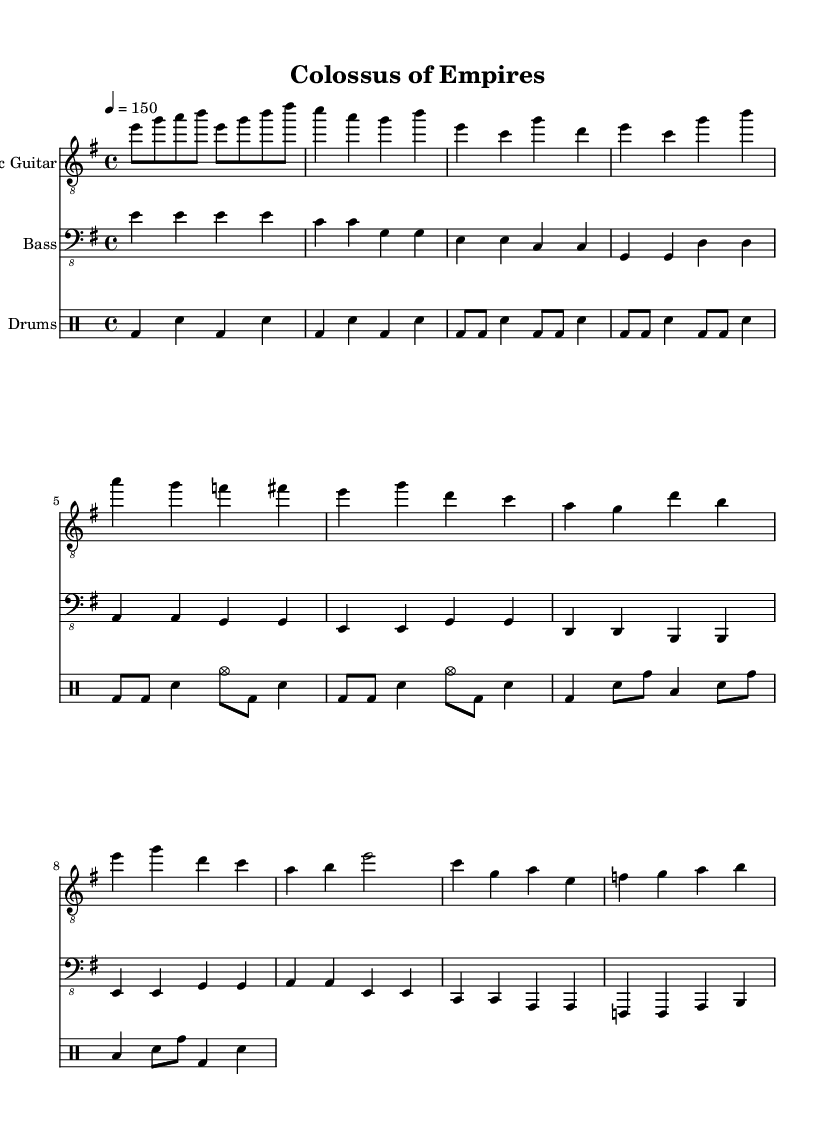What is the key signature of this music? The key signature is E minor, which has one sharp (F#). This is indicated by the 'e' in the key signature mentioned at the beginning of the score.
Answer: E minor What is the time signature of this music? The time signature is 4/4, which indicates that there are four beats in each measure, and a quarter note receives one beat. This can be observed at the start of the score where it is explicitly notated.
Answer: 4/4 What is the tempo marking for this piece? The tempo marking for this piece is 150 beats per minute, indicated by '4 = 150' at the beginning of the score. This means the tempo should be played at a moderate to fast pace.
Answer: 150 How many measures are in the introduction section? The introduction section contains 4 measures, as shown by the grouping of the notes written before the verse begins, which is clearly marked with the respective musical notation.
Answer: 4 What instrument plays the melody in the chorus section? The Electric Guitar plays the melody in the chorus section, as evidenced by its notation controls and the specific melodic lines characterized by higher octave note sequences in the score.
Answer: Electric Guitar Which part has a bridge that features toms? The drums part has a bridge that features toms, as noted in the section of the score where tom hits (indicated as 'tomh' and 'toml') are present, which is a typical feature in many power metal compositions.
Answer: Drums What is the dominant note in the verse section? The dominant note in the verse section appears to be E, as it's frequently repeated and is a significant tonal center for both electric and bass guitars in this part of the music.
Answer: E 